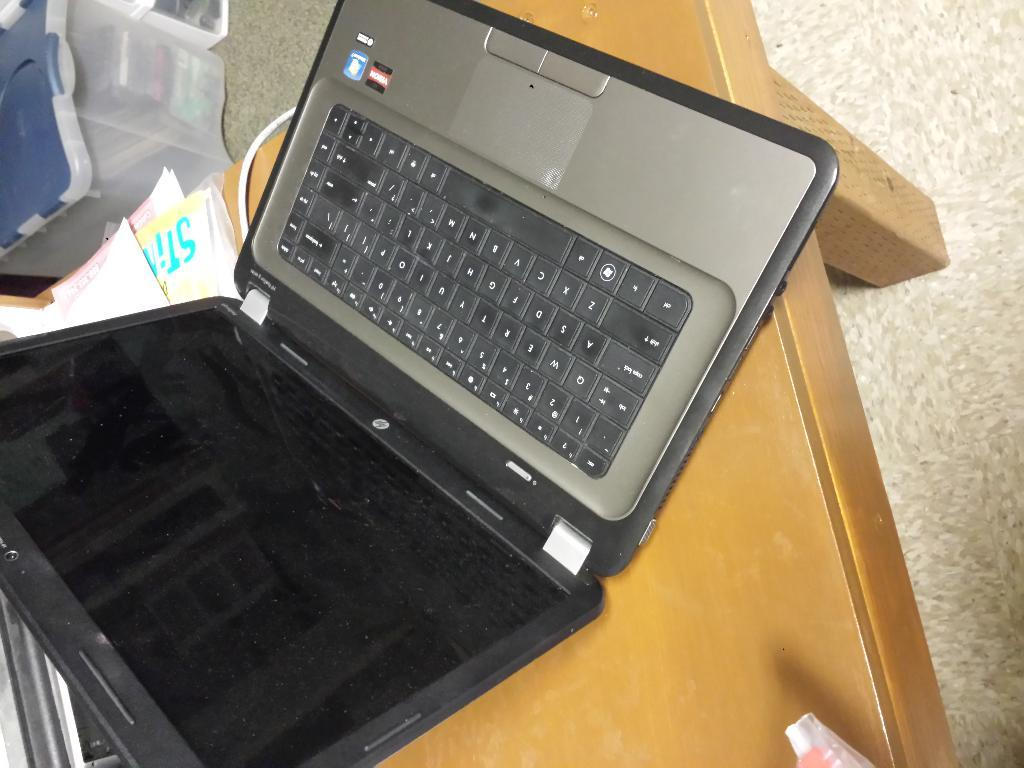<image>
Create a compact narrative representing the image presented. a laptop is laying on a table on top if a piece of paper that says STIn 